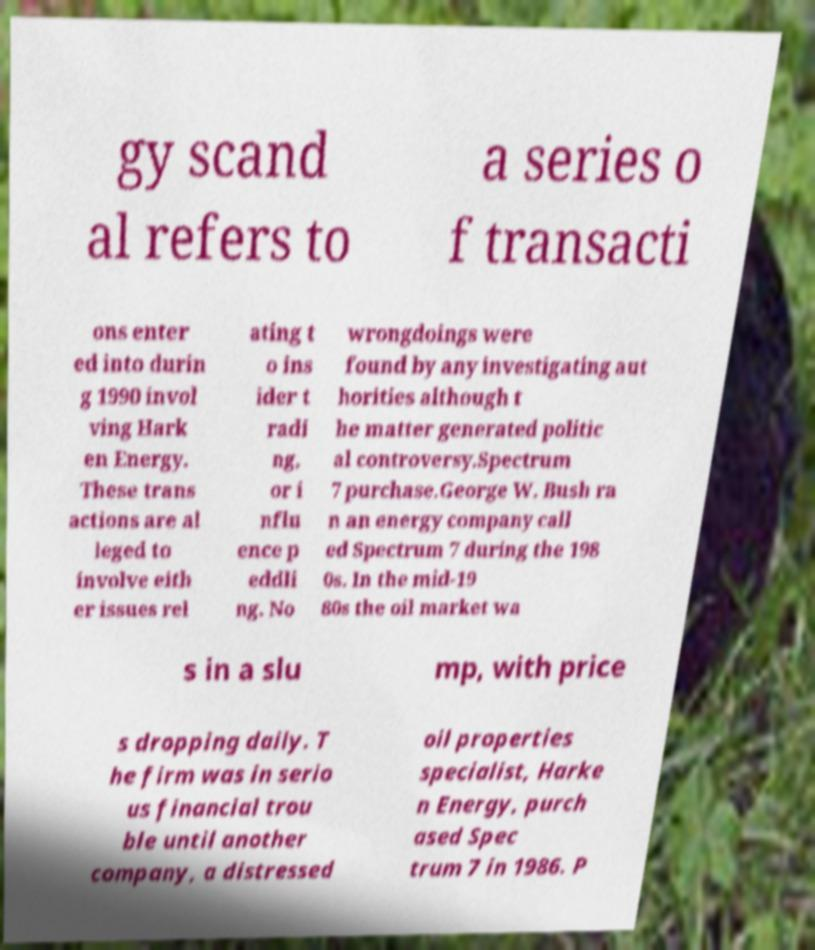Could you assist in decoding the text presented in this image and type it out clearly? gy scand al refers to a series o f transacti ons enter ed into durin g 1990 invol ving Hark en Energy. These trans actions are al leged to involve eith er issues rel ating t o ins ider t radi ng, or i nflu ence p eddli ng. No wrongdoings were found by any investigating aut horities although t he matter generated politic al controversy.Spectrum 7 purchase.George W. Bush ra n an energy company call ed Spectrum 7 during the 198 0s. In the mid-19 80s the oil market wa s in a slu mp, with price s dropping daily. T he firm was in serio us financial trou ble until another company, a distressed oil properties specialist, Harke n Energy, purch ased Spec trum 7 in 1986. P 